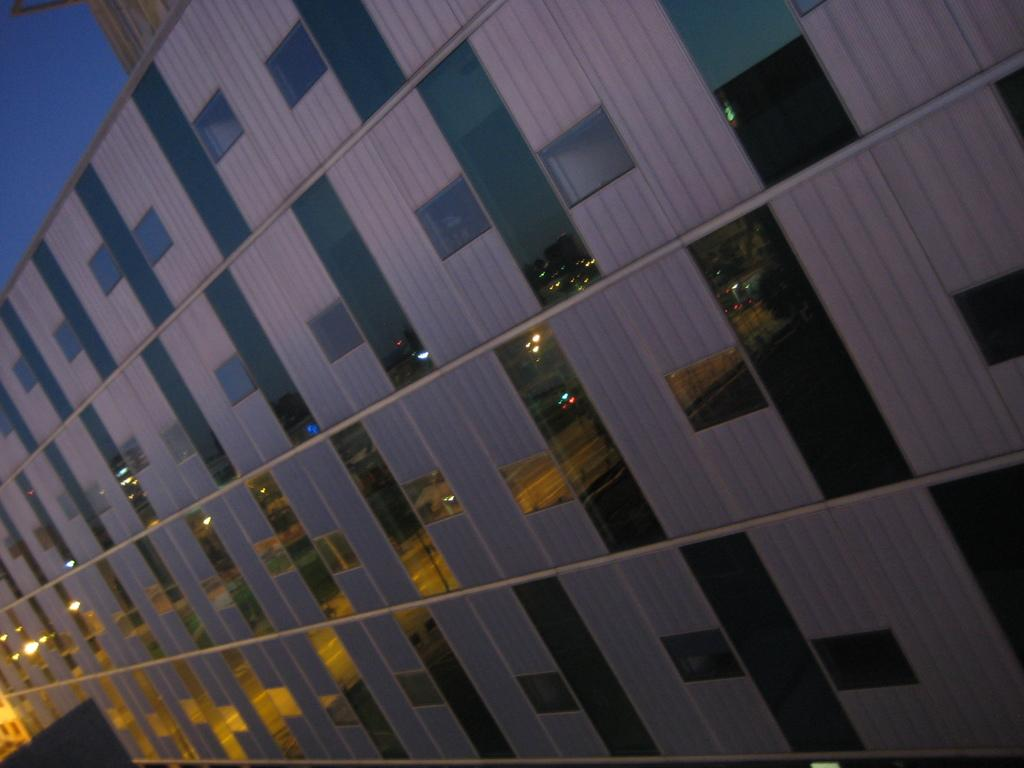What type of partition can be seen in the image? There is a partition designed in a box shape in the image. What can be seen in the background of the image? There is a road, street lights, grass, plants, trees, and the sky visible in the background of the image. What type of bead is used to decorate the stocking in the image? There is no bead or stocking present in the image. What is being served for dinner in the image? There is no dinner or food being served in the image. 